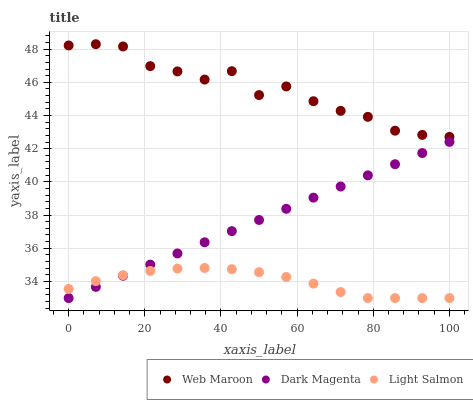Does Light Salmon have the minimum area under the curve?
Answer yes or no. Yes. Does Web Maroon have the maximum area under the curve?
Answer yes or no. Yes. Does Dark Magenta have the minimum area under the curve?
Answer yes or no. No. Does Dark Magenta have the maximum area under the curve?
Answer yes or no. No. Is Dark Magenta the smoothest?
Answer yes or no. Yes. Is Web Maroon the roughest?
Answer yes or no. Yes. Is Web Maroon the smoothest?
Answer yes or no. No. Is Dark Magenta the roughest?
Answer yes or no. No. Does Light Salmon have the lowest value?
Answer yes or no. Yes. Does Web Maroon have the lowest value?
Answer yes or no. No. Does Web Maroon have the highest value?
Answer yes or no. Yes. Does Dark Magenta have the highest value?
Answer yes or no. No. Is Dark Magenta less than Web Maroon?
Answer yes or no. Yes. Is Web Maroon greater than Dark Magenta?
Answer yes or no. Yes. Does Light Salmon intersect Dark Magenta?
Answer yes or no. Yes. Is Light Salmon less than Dark Magenta?
Answer yes or no. No. Is Light Salmon greater than Dark Magenta?
Answer yes or no. No. Does Dark Magenta intersect Web Maroon?
Answer yes or no. No. 